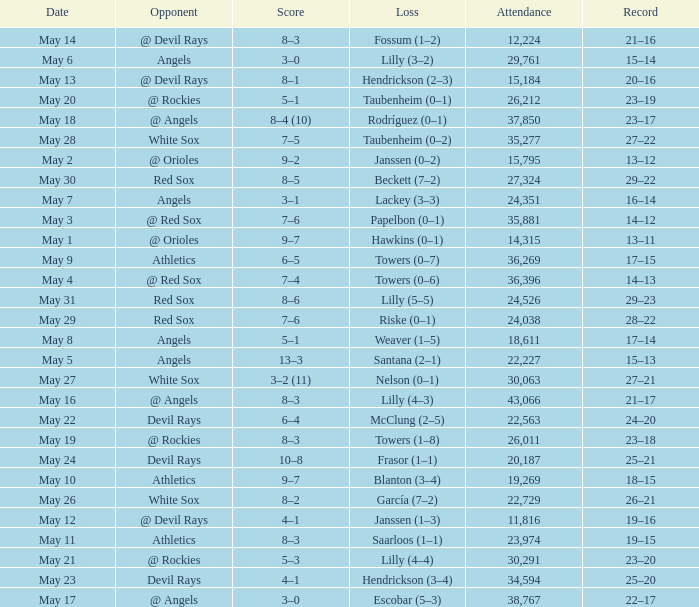What was the average attendance for games with a loss of papelbon (0–1)? 35881.0. 